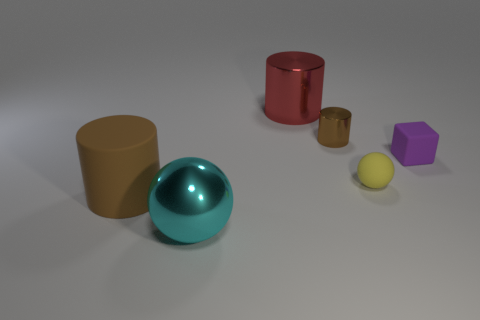There is a sphere that is right of the small shiny cylinder; is its size the same as the sphere that is left of the small yellow object?
Provide a short and direct response. No. What is the size of the rubber object that is on the right side of the tiny matte ball?
Your response must be concise. Small. What number of things are objects that are to the left of the red shiny cylinder or cylinders that are on the left side of the tiny brown metal cylinder?
Provide a succinct answer. 3. Is there anything else of the same color as the block?
Your response must be concise. No. Are there an equal number of big spheres that are to the right of the yellow thing and large things behind the large brown rubber cylinder?
Offer a terse response. No. Is the number of rubber balls that are on the left side of the shiny sphere greater than the number of brown metallic objects?
Offer a very short reply. No. How many objects are either matte objects on the right side of the red metal cylinder or shiny cylinders?
Offer a very short reply. 4. How many other things have the same material as the red object?
Ensure brevity in your answer.  2. There is a large object that is the same color as the tiny metal object; what shape is it?
Offer a very short reply. Cylinder. Is there a yellow matte thing that has the same shape as the brown matte thing?
Your answer should be compact. No. 